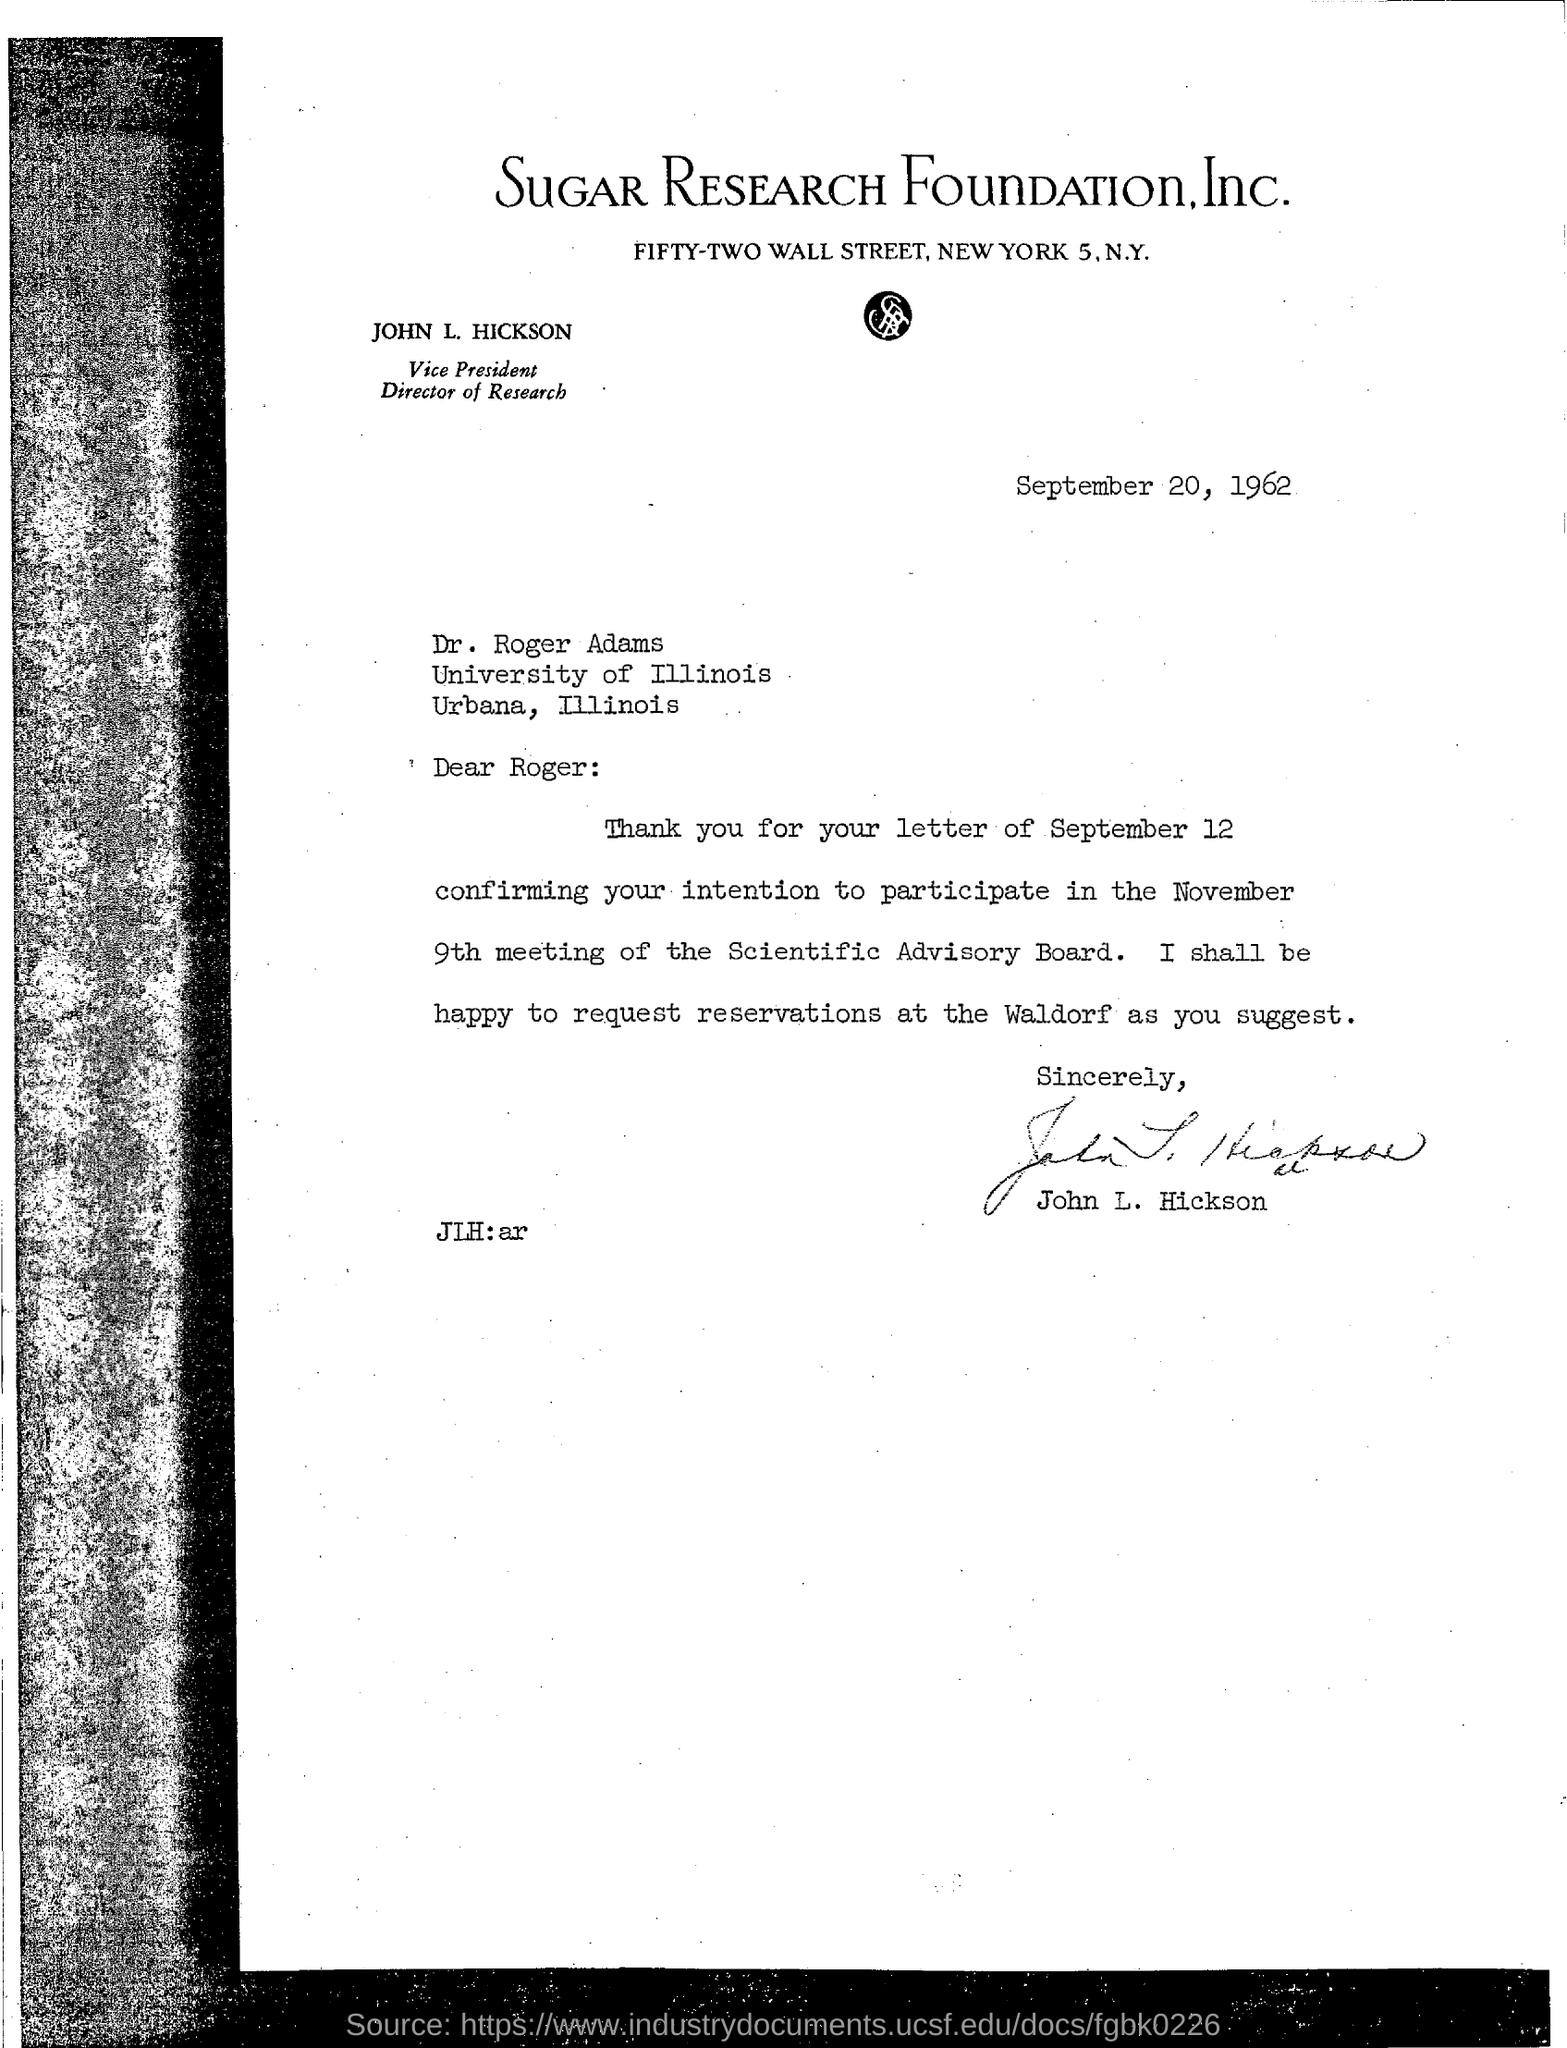When is the document dated?
Provide a short and direct response. September 20, 1962. Who is the Vice President and Director of Research?
Provide a succinct answer. JOHN L. HICKSON. When is the meeting going to be held?
Ensure brevity in your answer.  NOVEMBER 9TH. 